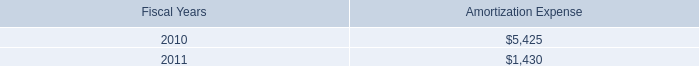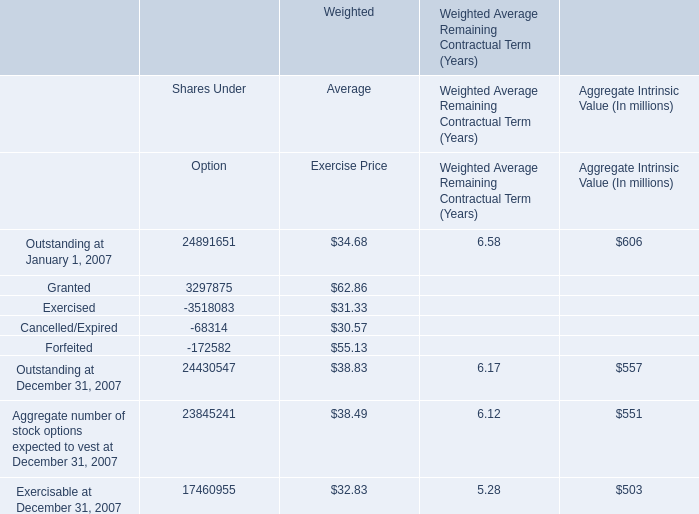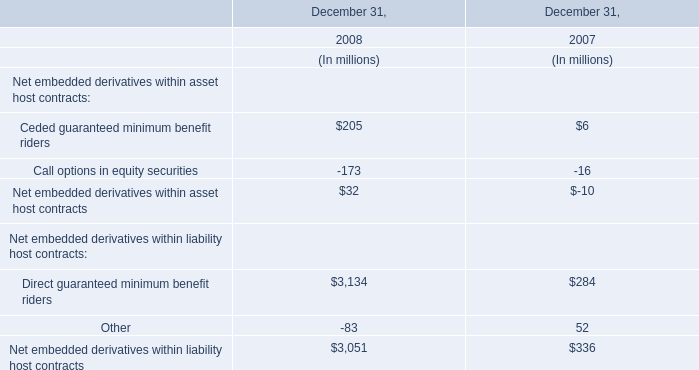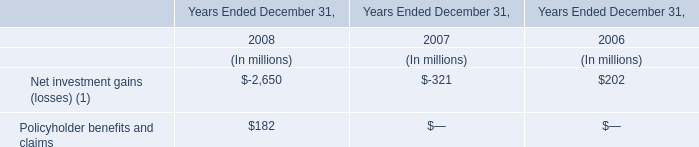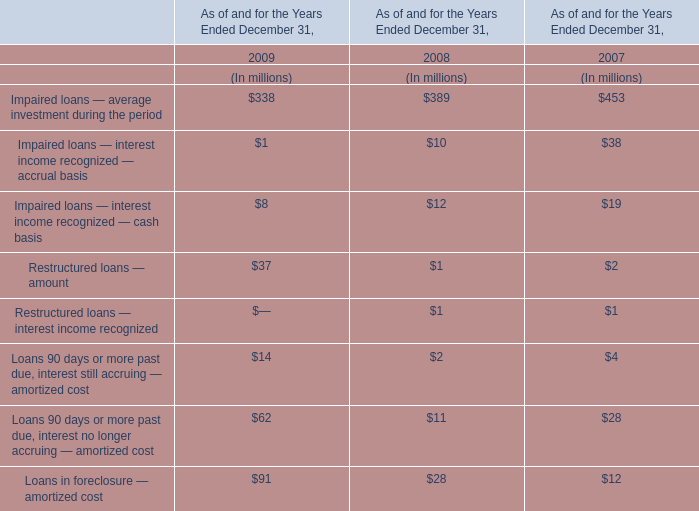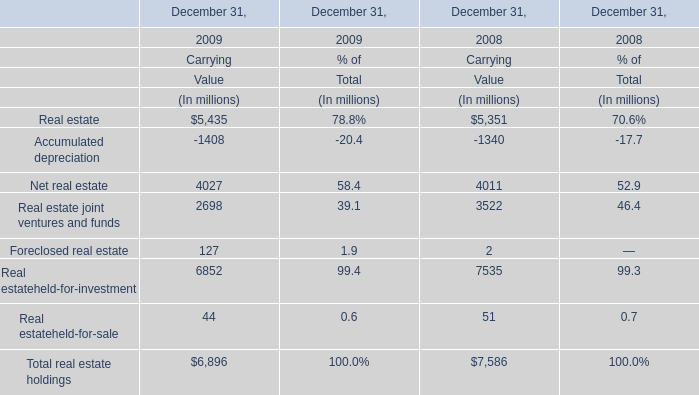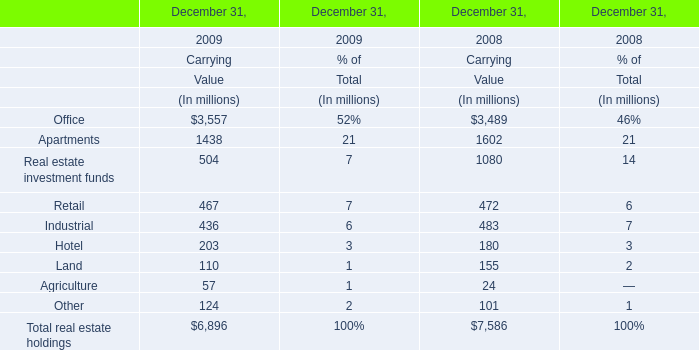What is the ratio of Industrial to the total in 2009 ? (in %) 
Answer: 6. 